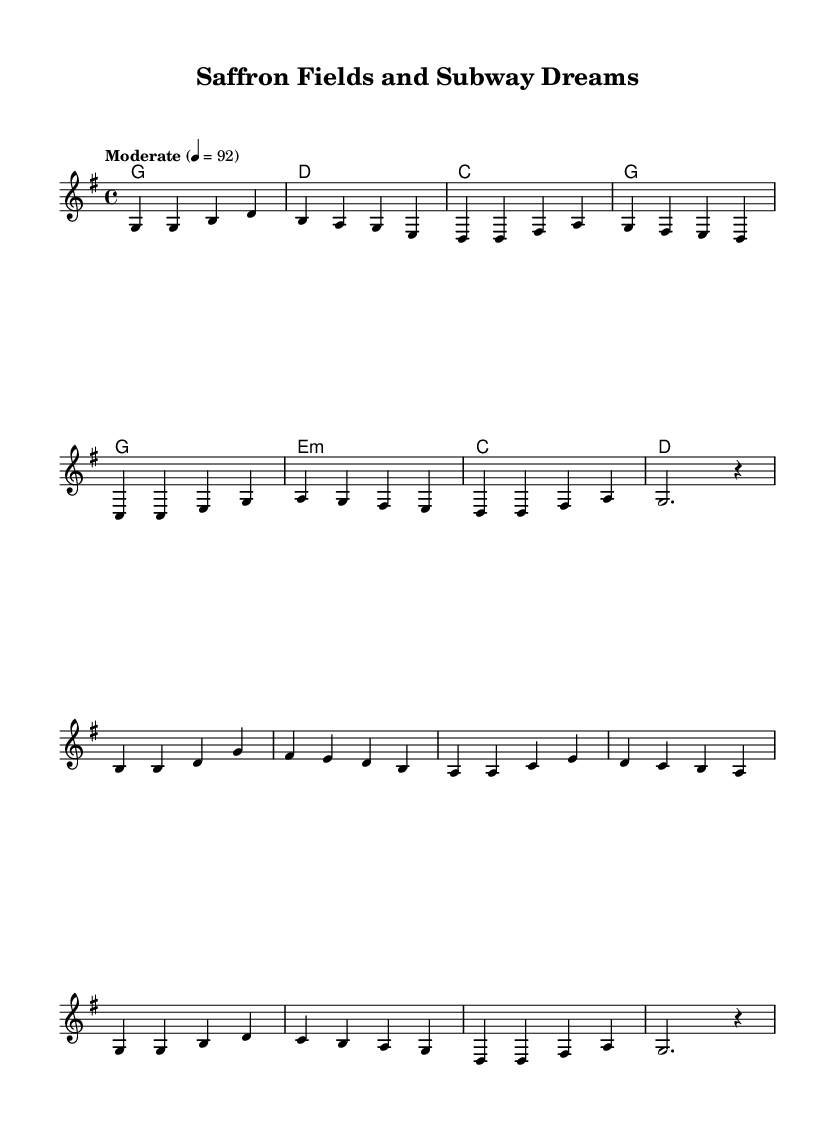What is the key signature of this music? The key signature indicated by the absence of any sharps or flats shows that this piece is in G major, which has one sharp.
Answer: G major What is the time signature of this music? The time signature shown in the beginning of the sheet music indicates that it is in 4/4 time, meaning there are four beats in each measure.
Answer: 4/4 What is the tempo marking for this piece? The tempo marking provided tells us that the piece should be played at a "Moderate" pace, set at 92 beats per minute.
Answer: Moderate How many measures are in the verse section? By counting the measures in the melody part labeled "Verse," we see there are a total of eight measures in this section.
Answer: 8 Which chord follows the 'G' chord in the chorus? Following the analysis of the chords in the chorus, the chord that comes after the 'G' chord is 'E minor'.
Answer: E minor What is the last note of the melody? Looking closely at the melody notation, the last note in the last measure is a rest, indicating a pause instead of a note at that point.
Answer: Rest What section does the melody return to after the chorus? Observing the structure, after the chorus, the piece returns to the verse section again for its repetition.
Answer: Verse 